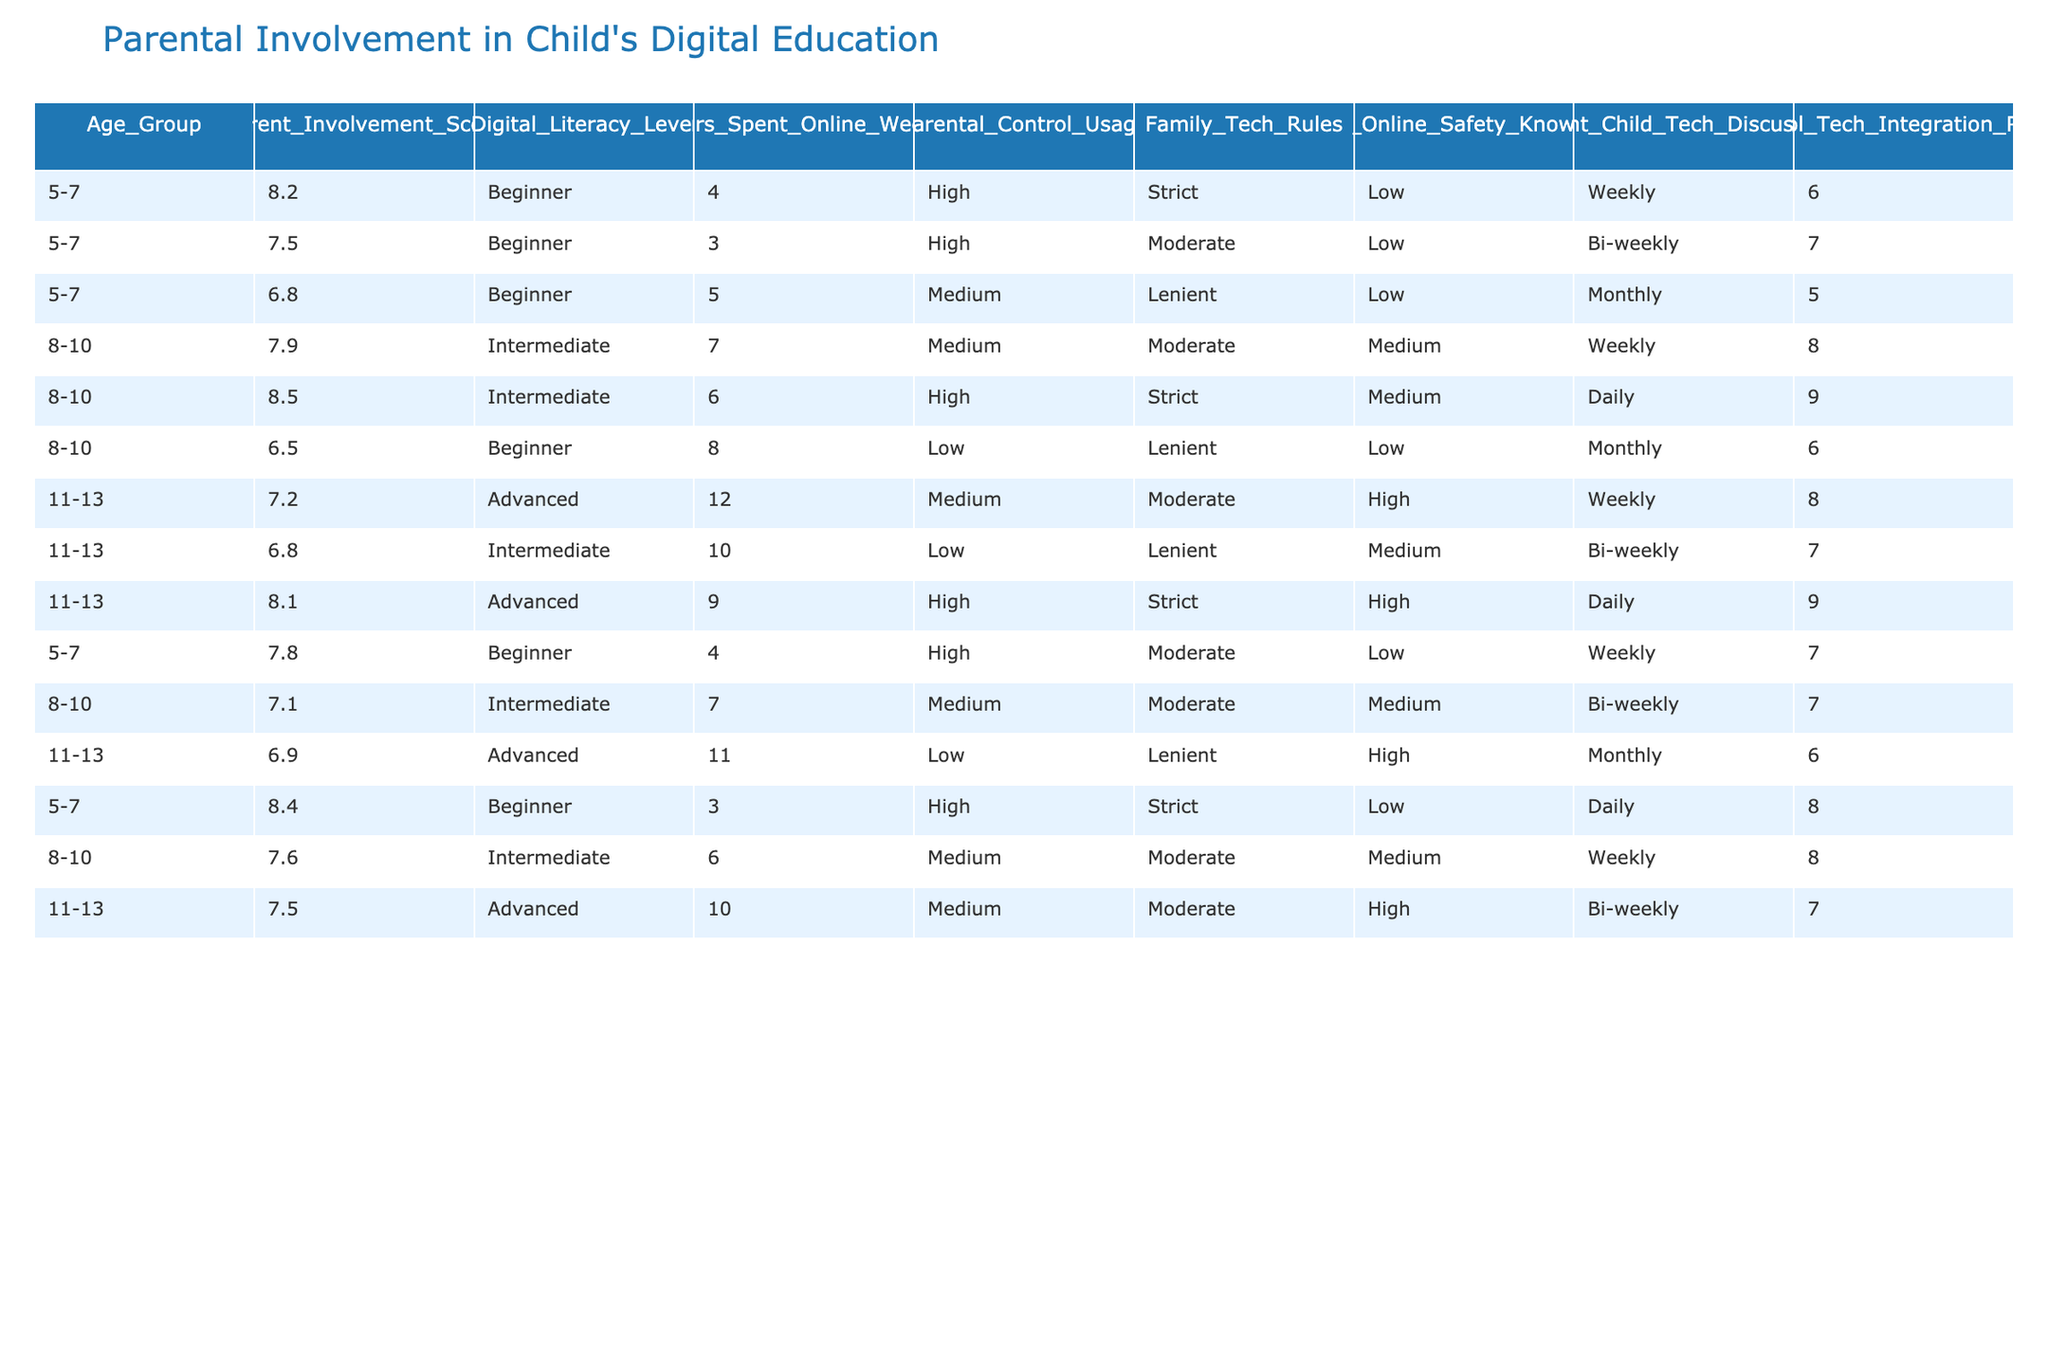What is the parental involvement score for the age group 5-7? In the age group 5-7, the parental involvement scores are 8.2, 7.5, 6.8, 7.8, and 8.4. The highest score among these is 8.4, and the lowest is 6.8. However, to answer specifically, any of the individual scores could be referred to since they all fall within that group.
Answer: 8.2, 7.5, 6.8, 7.8, 8.4 What is the digital literacy level of children in the age group 8-10? The digital literacy levels for the age group 8-10 include Intermediate and Beginner. The scores listed are 7.9 (Intermediate), 8.5 (Intermediate), and 6.5 (Beginner).
Answer: Intermediate, Beginner Which age group has the highest average parental involvement score? To find the average parental involvement score for each age group, we calculate: For 5-7: (8.2 + 7.5 + 6.8 + 7.8 + 8.4) / 5 = 7.774. For 8-10: (7.9 + 8.5 + 6.5 + 7.1 + 7.6) / 5 = 7.72. For 11-13: (7.2 + 6.8 + 8.1 + 6.9 + 7.5) / 5 = 7.5. The highest average is for the 5-7 age group with 7.774.
Answer: 5-7 What is the relationship between parental control usage and child online safety knowledge for the age group 11-13? In the age group 11-13, there are different parental control usages (Medium, Low, High) with corresponding child online safety knowledge (High, Medium, High). Both the scores showing High safety knowledge utilize High or Medium control, suggesting a potential correlation.
Answer: Yes, there is a correlation How many hours on average do children aged 8-10 spend online weekly? To find the average hours spent online for children aged 8-10, we sum their hours: 7 + 6 + 8 + 7 + 6 = 34 hours and divide by 5 (the number of entries). Therefore, 34 / 5 = 6.8 hours weekly on average.
Answer: 6.8 hours Does the use of strict parental controls correlate with higher parental involvement scores? Observing the parental involvement scores and control usage: 5-7 age group with strict control has scores of 8.2, 7.5, and 8.4 (high scores). In contrast, where controls are low (6.5) or lenient (6.8), the scores are lower. Thus, strict controls seem linked with higher scores.
Answer: Yes, it appears so What is the frequency of parent-child tech discussions for children aged 5-7? The frequency of parent-child tech discussions for age group 5-7 are Weekly, Bi-weekly, Monthly, and Daily. The most common frequency listed is Weekly, as it appears multiple times.
Answer: Weekly What is the average digital literacy level for the age group 11-13? The digital literacy levels for the 11-13 age group include Advanced and Intermediate: 7.2 (Advanced), 6.8 (Intermediate), 8.1 (Advanced), 6.9 (Advanced), 7.5 (Advanced). To average these numeric categories, Advanced (8) is higher than Intermediate (7) skewing the average toward Advanced. Many 'Advanced' instances suggest an overall higher level.
Answer: Advanced 